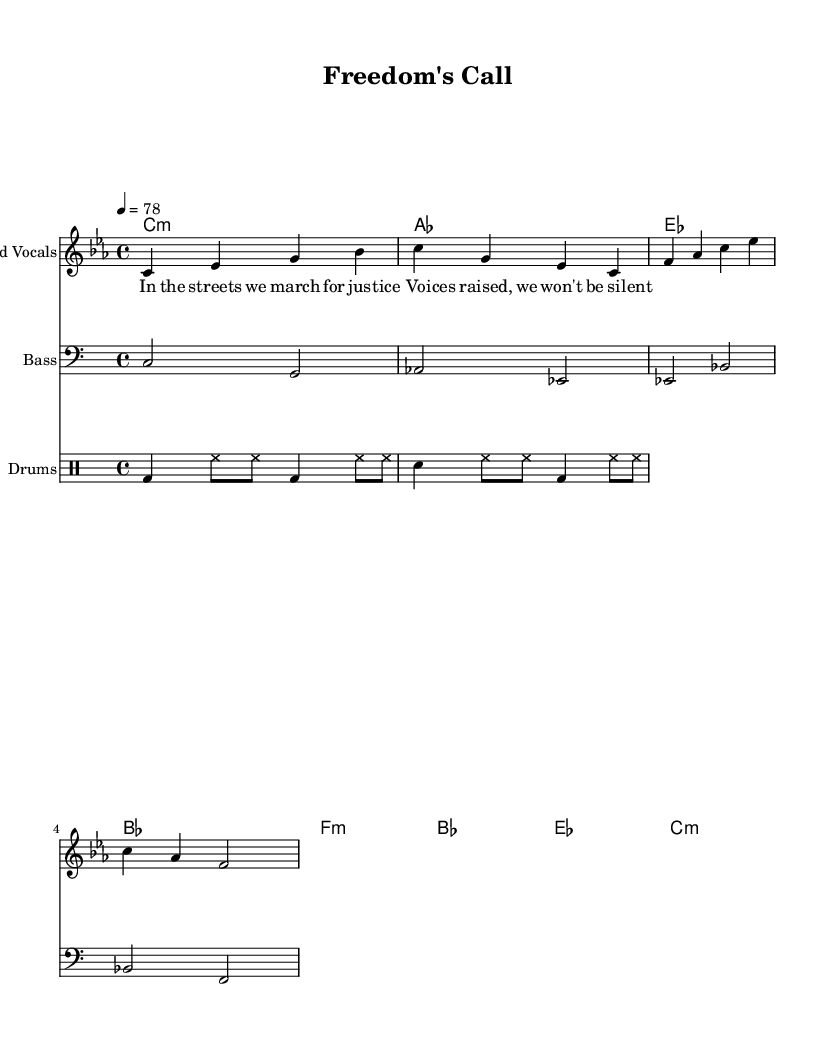What is the key signature of this music? The key signature indicates C minor, which has three flats: B flat, E flat, and A flat. This is determined by examining the key signature indicated at the beginning of the score.
Answer: C minor What is the time signature of the piece? The time signature shown at the beginning of the score is 4/4, which means there are four beats in each measure and the quarter note gets one beat. This can be identified from the notation that appears after the key signature.
Answer: 4/4 What is the tempo marking of the song? The tempo marking indicates a speed of 78 beats per minute, which is specified in the score as "4 = 78". This is found in the tempo indication next to the time signature.
Answer: 78 What instruments are included in this arrangement? The arrangement includes lead vocals, bass, and drums, each indicated by the respective staff headings in the score. The specific names of the instruments can be found labeled above each part.
Answer: Lead Vocals, Bass, Drums What is the theme expressed in the lyrics? The theme reflected in the lyrics emphasizes justice and vocalizing for rights, which can be inferred from the content of the verse provided on the score. The lyrics mention marching for justice and raising voices, highlighting a social commentary theme.
Answer: Justice How many measures are there in the melody? The melody consists of four measures as indicated by the division of the melody part into separate bars. You can count the number of vertical lines indicating measure separations in the melody.
Answer: Four What type of rhythmic pattern is used in the drums part? The rhythmic pattern in the drums consists of a combination of bass drum (bd) and snare drum (sn) hits, with high-hat (hh) accents, typical of reggae music's laid-back groove. This can be analyzed through the drummode notation which shows the organization of drum sounds.
Answer: Reggae groove 